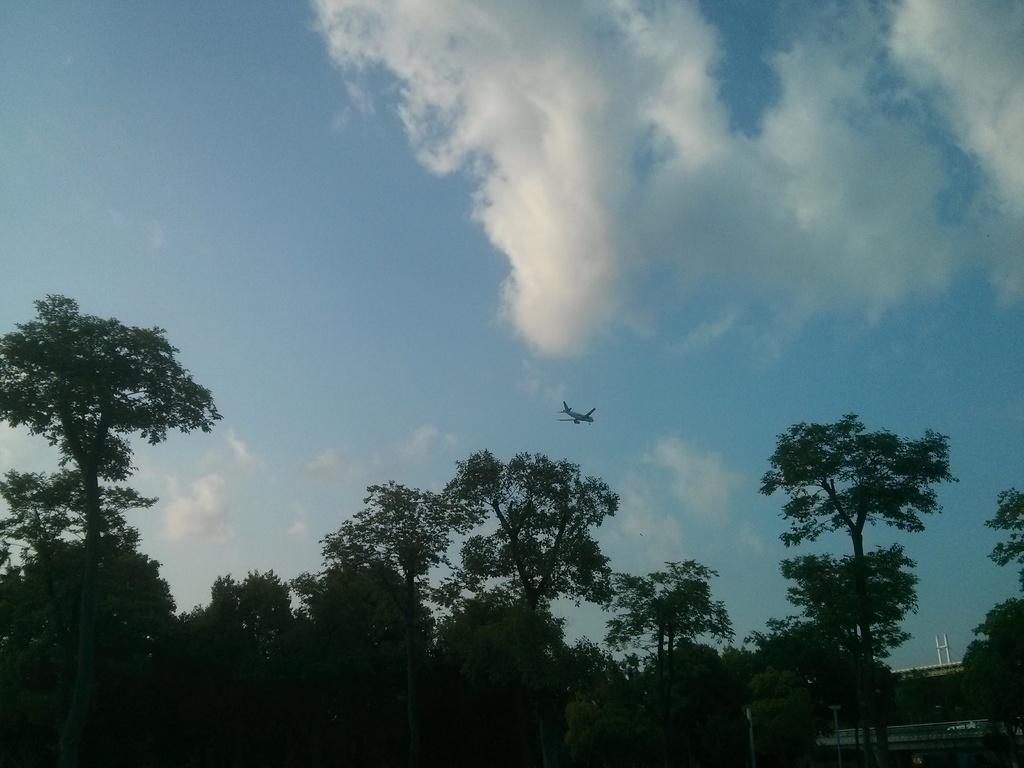What type of vegetation can be seen in the image? There are trees in the image. What is located in the background of the image? There is an aeroplane and the sky visible in the background of the image. What title is given to the aeroplane in the image? There is no title given to the aeroplane in the image, as it is not a specific aeroplane but rather a general representation of one. 